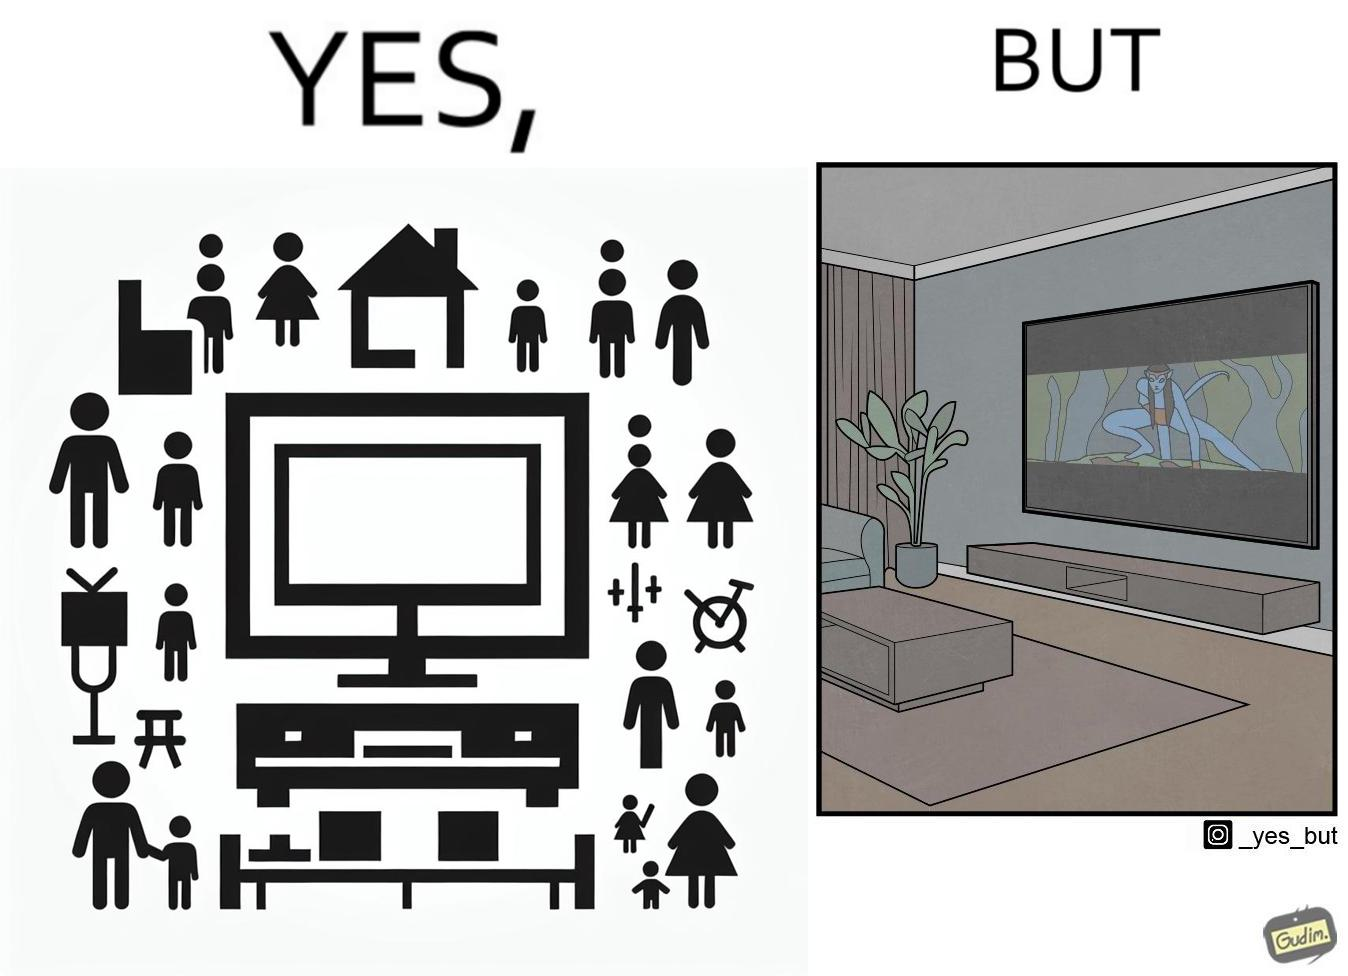Provide a description of this image. The image is funny because while the room has a big TV with a big screen, the movie being played on it does not use the entire screen. 